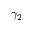Convert formula to latex. <formula><loc_0><loc_0><loc_500><loc_500>\gamma _ { 2 }</formula> 